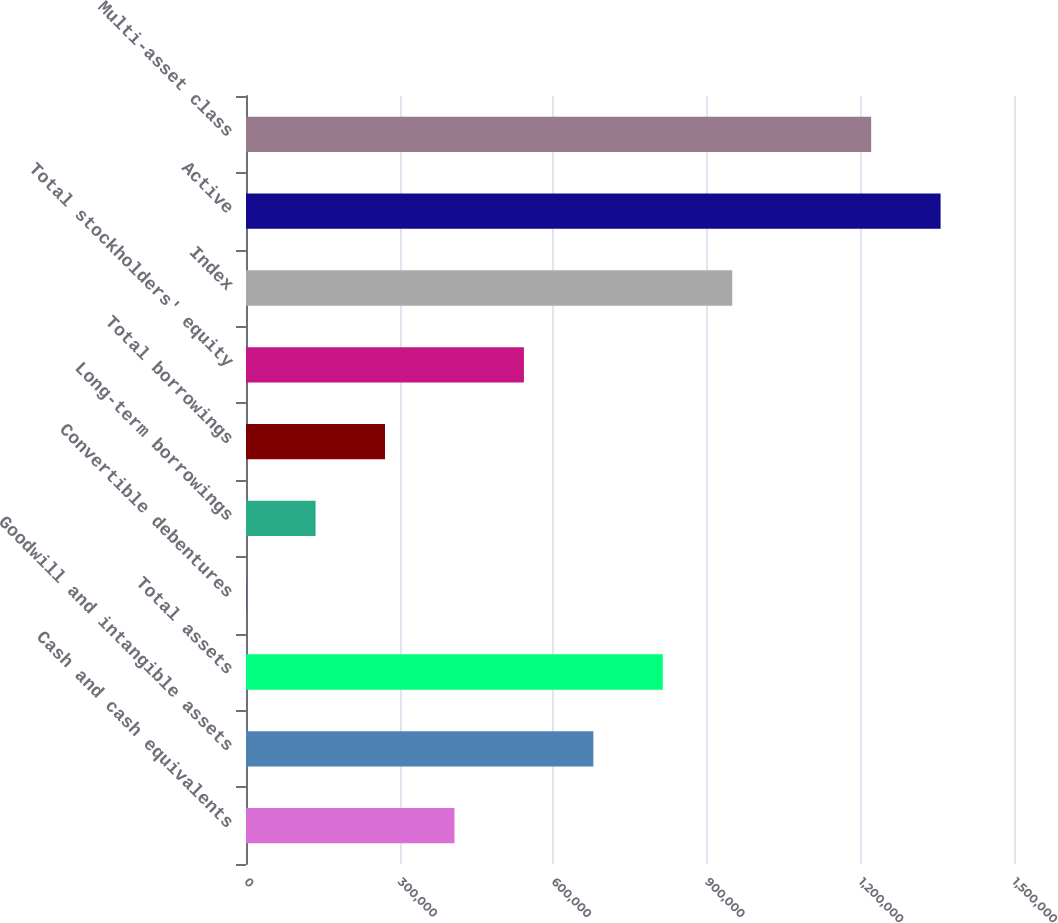<chart> <loc_0><loc_0><loc_500><loc_500><bar_chart><fcel>Cash and cash equivalents<fcel>Goodwill and intangible assets<fcel>Total assets<fcel>Convertible debentures<fcel>Long-term borrowings<fcel>Total borrowings<fcel>Total stockholders' equity<fcel>Index<fcel>Active<fcel>Multi-asset class<nl><fcel>407163<fcel>678443<fcel>814083<fcel>242<fcel>135882<fcel>271522<fcel>542803<fcel>949723<fcel>1.35664e+06<fcel>1.221e+06<nl></chart> 